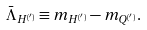Convert formula to latex. <formula><loc_0><loc_0><loc_500><loc_500>\bar { \Lambda } _ { H ^ { ( ^ { \prime } ) } } \equiv m _ { H ^ { ( ^ { \prime } ) } } - m _ { Q ^ { ( ^ { \prime } ) } } .</formula> 